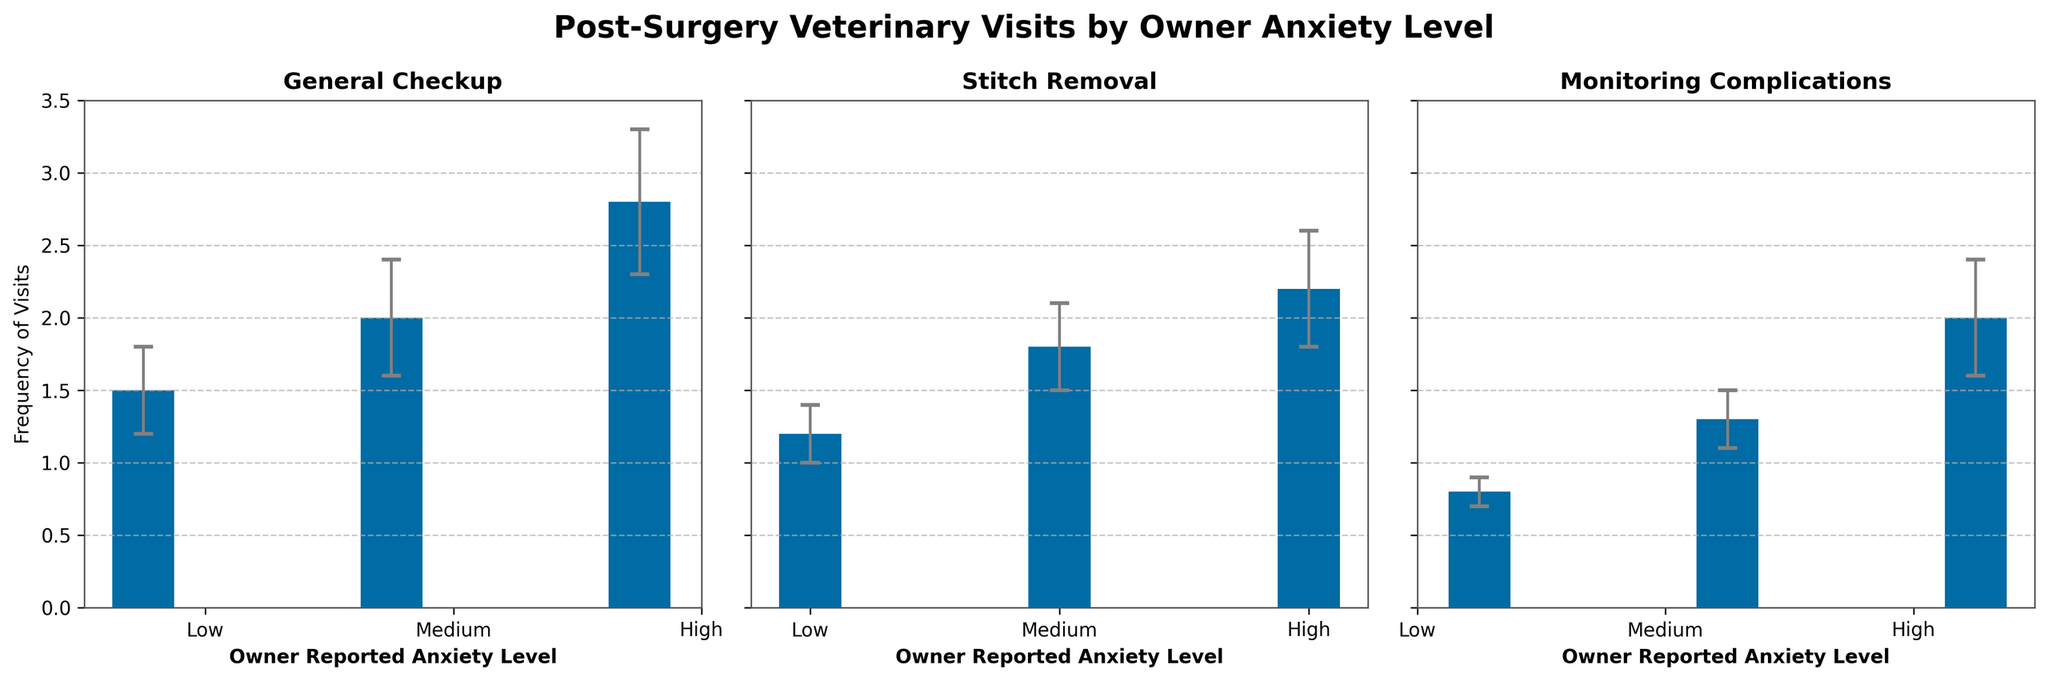What's the title of the figure? The title is usually located at the top of the figure. In this case, it reads "Post-Surgery Veterinary Visits by Owner Anxiety Level".
Answer: Post-Surgery Veterinary Visits by Owner Anxiety Level How many anxiety levels are compared in the figure? By examining the x-axis labels on each subplot, we can see that there are three distinct anxiety levels: Low, Medium, and High.
Answer: 3 Which visit type has the highest frequency under high anxiety levels? In the subplot titled "General Checkup", the bar for the High anxiety level is the tallest compared to the other visit types.
Answer: General Checkup What is the frequency of Stitch Removal visits for cats with medium anxiety? The height of the bar for Stitch Removal under Medium anxiety in the corresponding subplot indicates the frequency.
Answer: 1.8 Between Medium and High anxiety levels, in which category do Stitch Removal visits show a greater difference in frequency? By comparing the heights of the bars in the Stitch Removal subplot, we see that High anxiety has a slightly higher value than Medium anxiety. The difference is calculated as 2.2 - 1.8.
Answer: High anxiety, by 0.4 What is the average frequency of Monitoring Complications visits across all anxiety levels? To calculate the average, sum the frequencies for all anxiety levels: (0.8 + 1.3 + 2.0) = 4.1. Divide by the number of levels (3): 4.1 / 3 = 1.367.
Answer: Approximately 1.37 Are the frequencies of General Checkup visits for Low and Medium anxiety levels within the error bars of each other? The frequencies for Low and Medium anxiety are 1.5 (±0.3) and 2.0 (±0.4) respectively. The error range for Low is [1.2, 1.8], and for Medium is [1.6, 2.4]. These ranges overlap.
Answer: Yes How do error bars for Monitoring Complications visits change from Low to High anxiety levels? Observe the length of the error bars in the Monitoring Complications subplot; they increase from Low (±0.1) to High anxiety levels (±0.4).
Answer: They increase What is the difference in frequency of Monitoring Complications visits between Low and High anxiety? Subtract the frequency of Low anxiety (0.8) from High anxiety (2.0).
Answer: 1.2 Which visit type shows the smallest error across all anxiety levels? By comparing the length of the error bars in all subplots, Monitoring Complications in Low anxiety shows the smallest error (±0.1).
Answer: Monitoring Complications under Low anxiety 